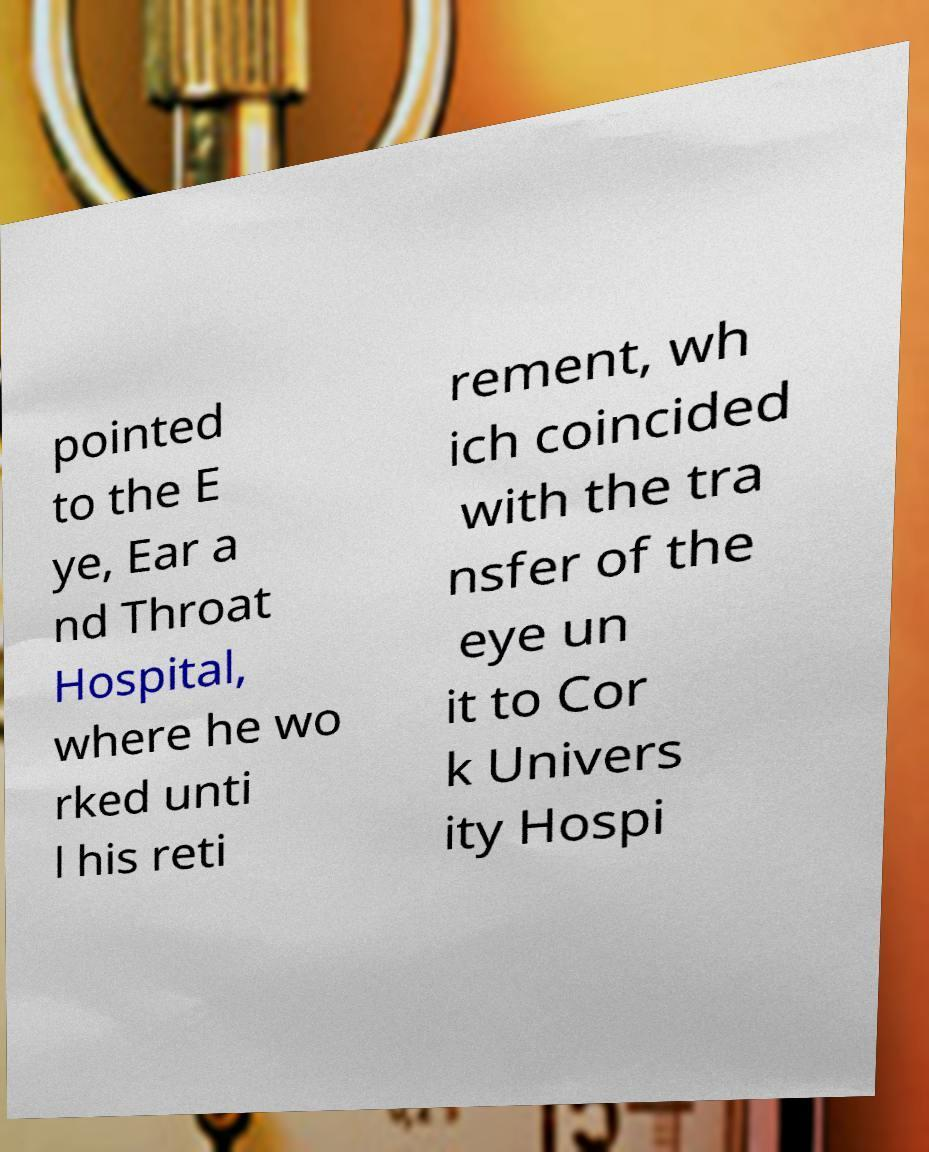Can you read and provide the text displayed in the image?This photo seems to have some interesting text. Can you extract and type it out for me? pointed to the E ye, Ear a nd Throat Hospital, where he wo rked unti l his reti rement, wh ich coincided with the tra nsfer of the eye un it to Cor k Univers ity Hospi 